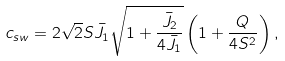Convert formula to latex. <formula><loc_0><loc_0><loc_500><loc_500>c _ { s w } = 2 \sqrt { 2 } S { \bar { J } } _ { 1 } \sqrt { 1 + \frac { { \bar { J } } _ { 2 } } { 4 { \bar { J } } _ { 1 } } } \left ( 1 + \frac { Q } { 4 S ^ { 2 } } \right ) ,</formula> 